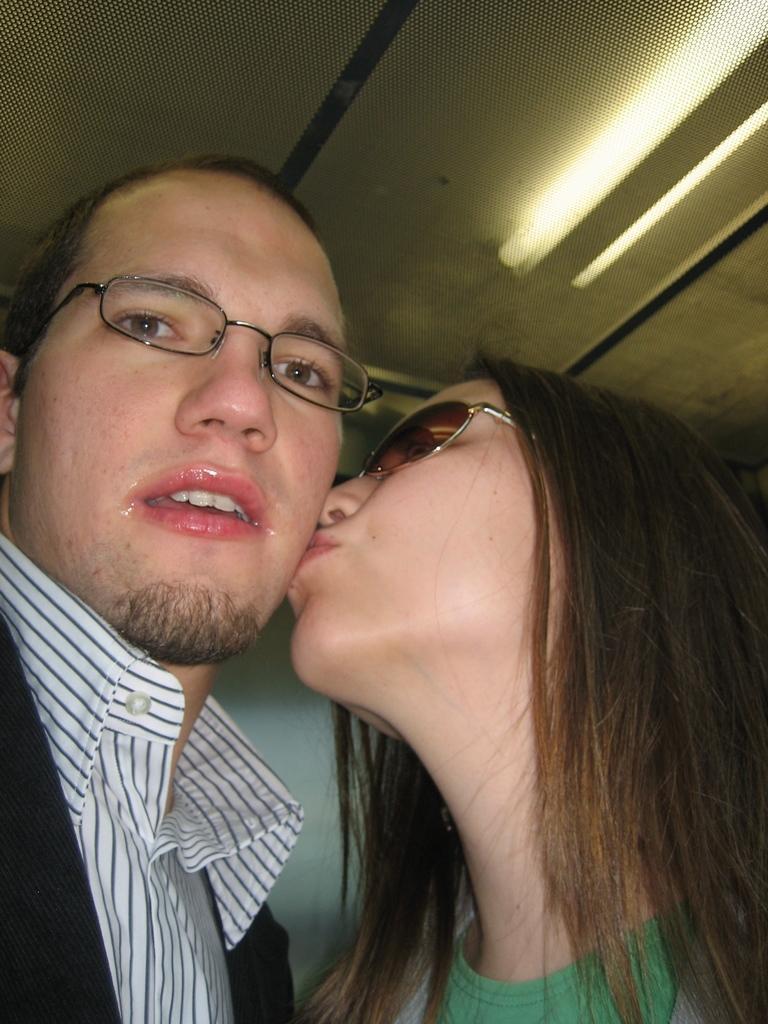How would you summarize this image in a sentence or two? In the foreground of the picture, there is a man and also a woman kissing on the cheek of the man. In the background, there are lights to the ceiling. 